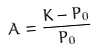Convert formula to latex. <formula><loc_0><loc_0><loc_500><loc_500>A = \frac { K - P _ { 0 } } { P _ { 0 } }</formula> 